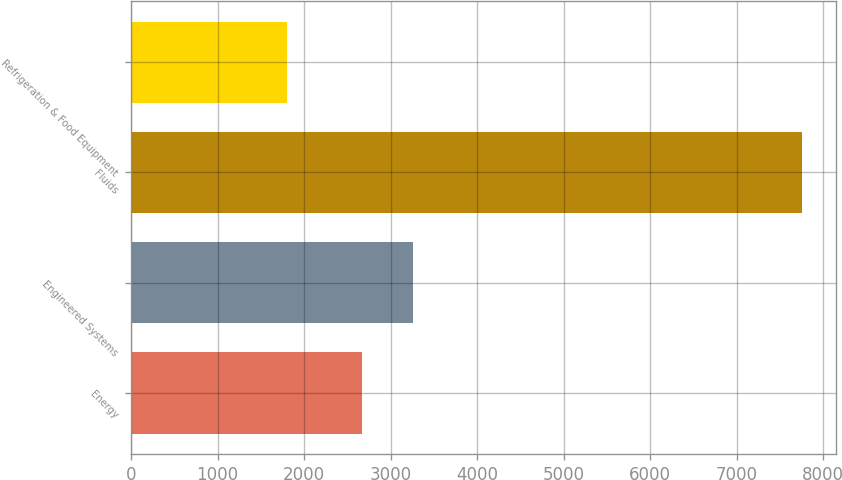Convert chart to OTSL. <chart><loc_0><loc_0><loc_500><loc_500><bar_chart><fcel>Energy<fcel>Engineered Systems<fcel>Fluids<fcel>Refrigeration & Food Equipment<nl><fcel>2668<fcel>3263.4<fcel>7756<fcel>1802<nl></chart> 